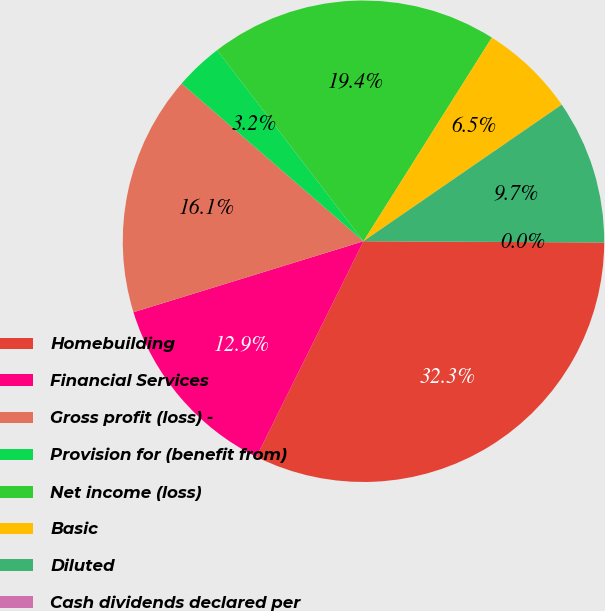Convert chart. <chart><loc_0><loc_0><loc_500><loc_500><pie_chart><fcel>Homebuilding<fcel>Financial Services<fcel>Gross profit (loss) -<fcel>Provision for (benefit from)<fcel>Net income (loss)<fcel>Basic<fcel>Diluted<fcel>Cash dividends declared per<nl><fcel>32.25%<fcel>12.9%<fcel>16.13%<fcel>3.23%<fcel>19.35%<fcel>6.45%<fcel>9.68%<fcel>0.0%<nl></chart> 